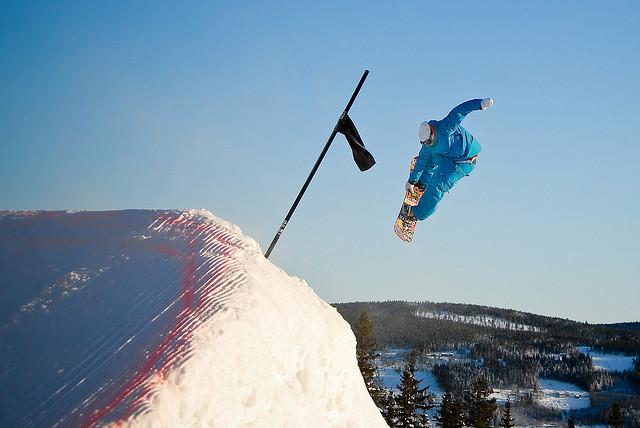What ski resort is that?
Be succinct. Snowshoe. Will the person fall?
Concise answer only. No. How high in the air is the person?
Quick response, please. High. 